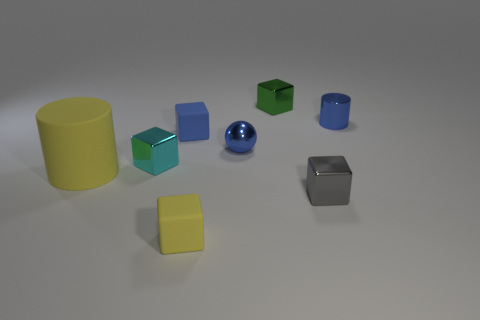Is there a small gray metal thing of the same shape as the large rubber object?
Your answer should be compact. No. Are the green cube and the cylinder behind the rubber cylinder made of the same material?
Provide a short and direct response. Yes. There is a metal object that is right of the gray block in front of the tiny cube to the left of the tiny blue cube; what is its color?
Keep it short and to the point. Blue. There is a blue cube that is the same size as the cyan metal object; what is it made of?
Ensure brevity in your answer.  Rubber. How many small blue spheres have the same material as the tiny cyan block?
Your answer should be compact. 1. Is the size of the cylinder that is in front of the blue cube the same as the blue metal thing that is in front of the tiny blue cylinder?
Offer a very short reply. No. There is a tiny matte thing in front of the small cyan metallic block; what is its color?
Keep it short and to the point. Yellow. There is a sphere that is the same color as the small cylinder; what material is it?
Your response must be concise. Metal. What number of tiny shiny balls have the same color as the small metallic cylinder?
Provide a succinct answer. 1. Do the green metallic block and the yellow object on the right side of the yellow cylinder have the same size?
Give a very brief answer. Yes. 